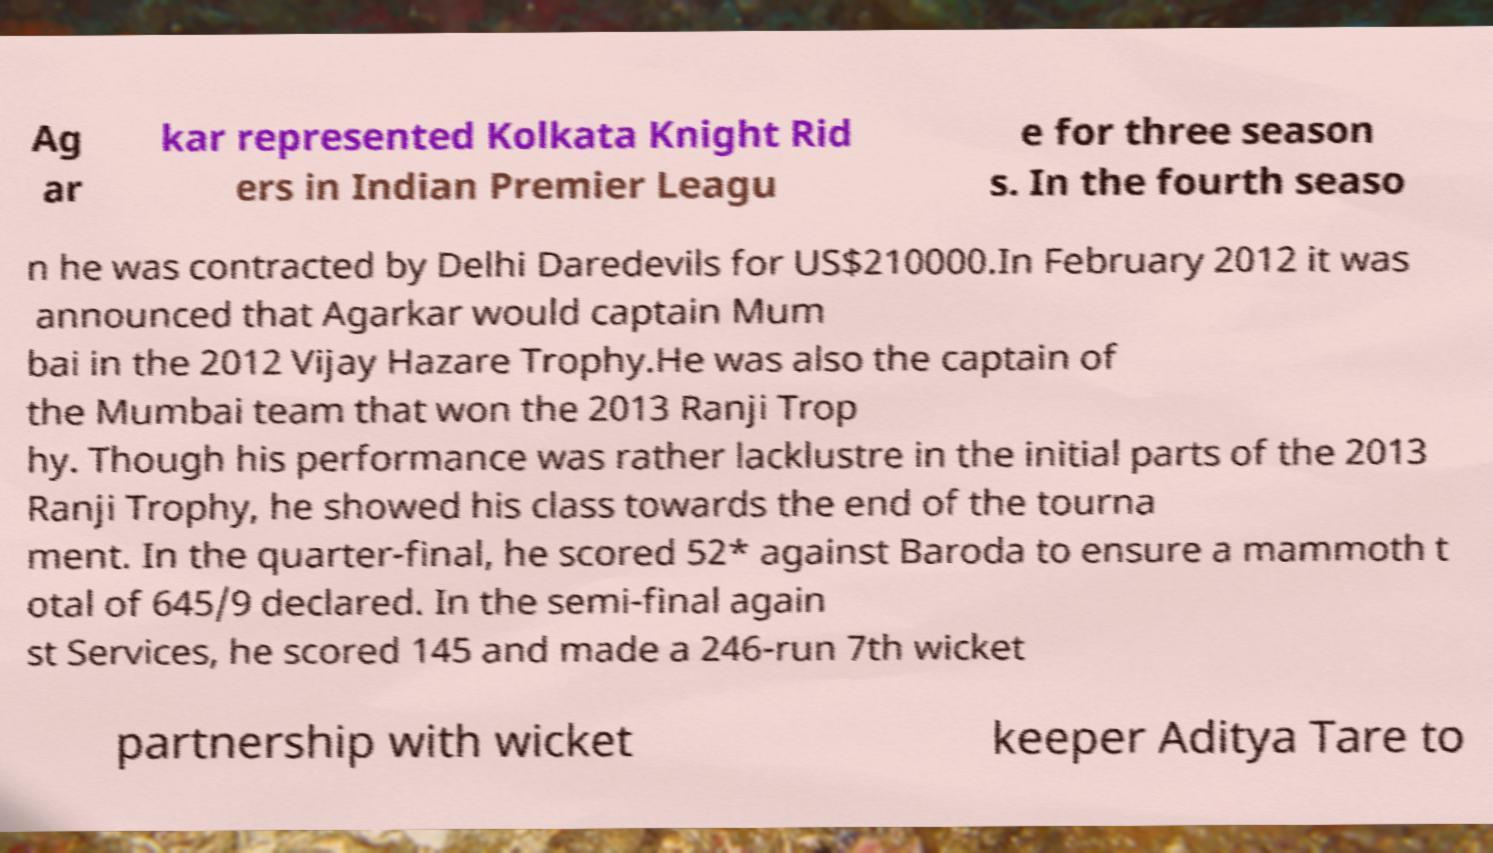Please read and relay the text visible in this image. What does it say? Ag ar kar represented Kolkata Knight Rid ers in Indian Premier Leagu e for three season s. In the fourth seaso n he was contracted by Delhi Daredevils for US$210000.In February 2012 it was announced that Agarkar would captain Mum bai in the 2012 Vijay Hazare Trophy.He was also the captain of the Mumbai team that won the 2013 Ranji Trop hy. Though his performance was rather lacklustre in the initial parts of the 2013 Ranji Trophy, he showed his class towards the end of the tourna ment. In the quarter-final, he scored 52* against Baroda to ensure a mammoth t otal of 645/9 declared. In the semi-final again st Services, he scored 145 and made a 246-run 7th wicket partnership with wicket keeper Aditya Tare to 